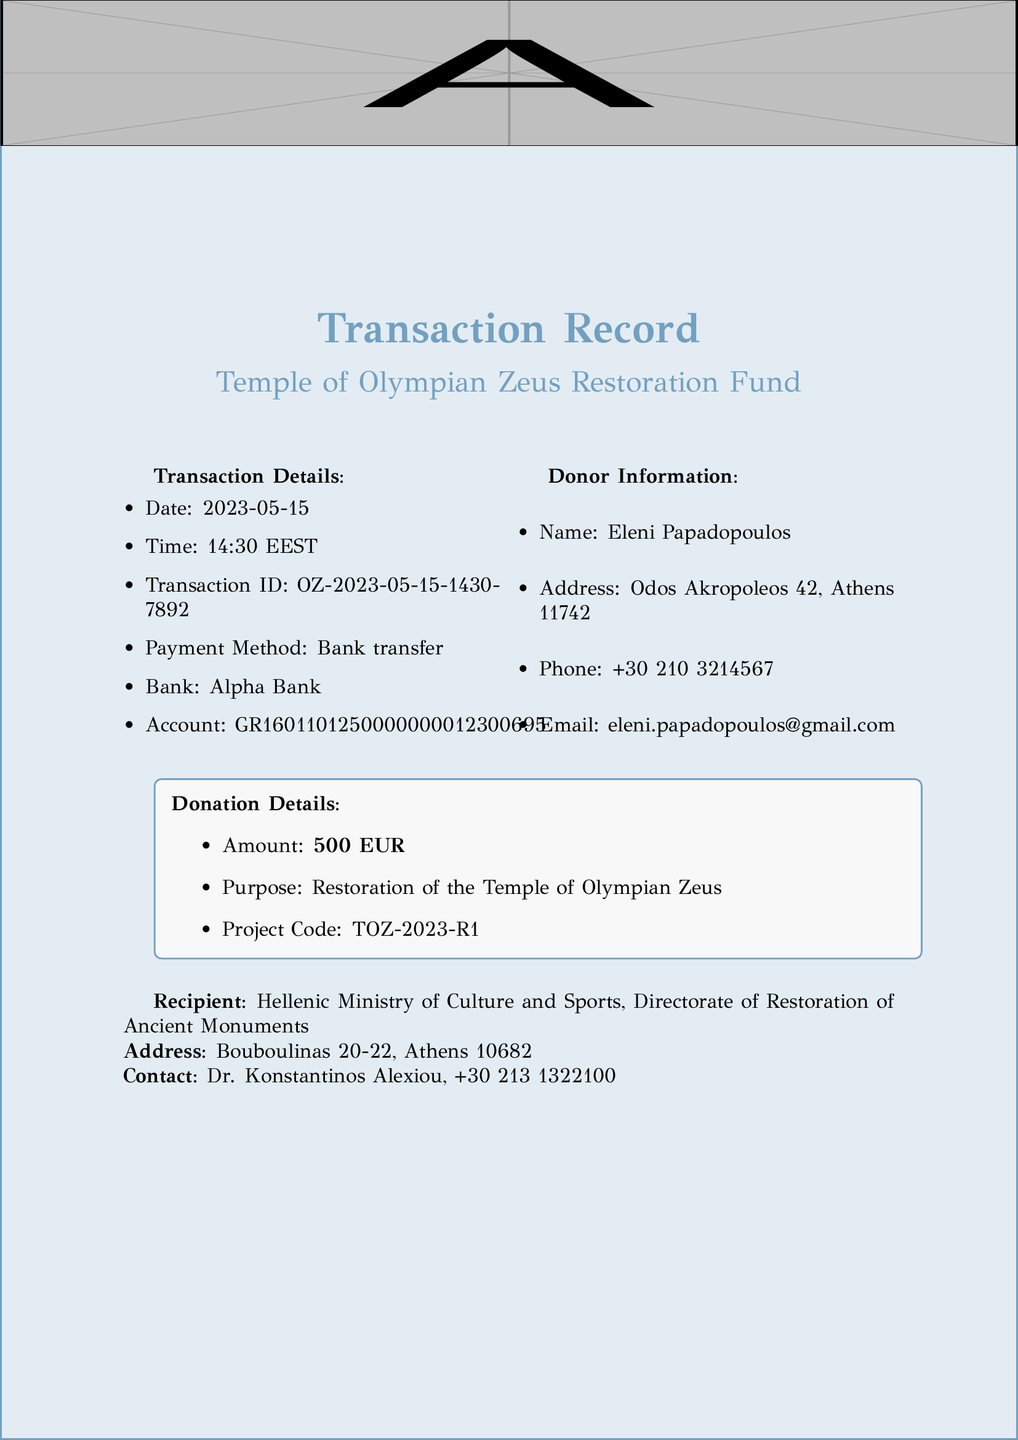What is the transaction date? The transaction date is specified in the document under transaction details.
Answer: 2023-05-15 Who is the donor? The name of the donor is provided in the donor information section of the document.
Answer: Eleni Papadopoulos What is the donation amount? The document indicates the total donation amount under donation details.
Answer: 500 EUR What is the project code? The project code assigned to the restoration is listed in the donation details.
Answer: TOZ-2023-R1 What organization will receive the donation? The recipient organization is noted in the document.
Answer: Hellenic Ministry of Culture and Sports What is the estimated completion date of the restoration project? This date is found under the restoration project section of the document.
Answer: 2025-12-31 How many original columns did the Temple of Olympian Zeus have? The document provides historical information about the original columns of the temple.
Answer: 104 What benefit is provided to donors regarding tax? The document mentions tax-related benefits for donors specifically.
Answer: Eligible for tax deduction under Greek law What is one main objective of the restoration project? The objectives of the restoration project are detailed under a specific section.
Answer: Stabilization of remaining columns 